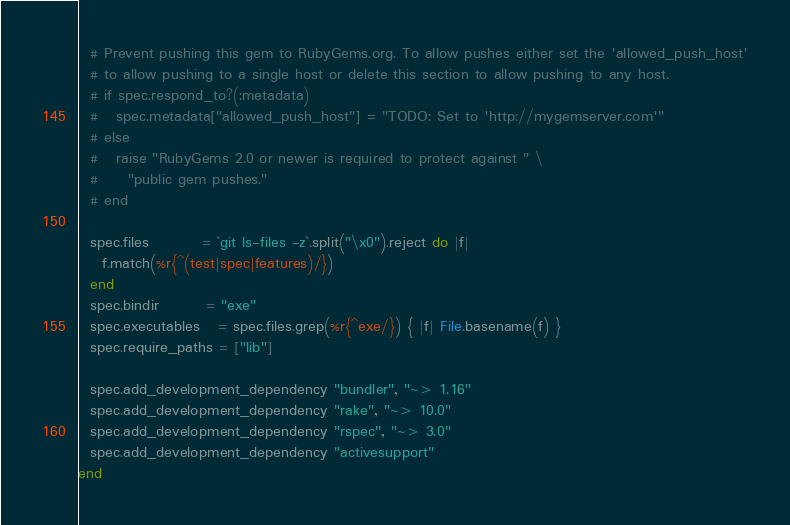<code> <loc_0><loc_0><loc_500><loc_500><_Ruby_>  # Prevent pushing this gem to RubyGems.org. To allow pushes either set the 'allowed_push_host'
  # to allow pushing to a single host or delete this section to allow pushing to any host.
  # if spec.respond_to?(:metadata)
  #   spec.metadata["allowed_push_host"] = "TODO: Set to 'http://mygemserver.com'"
  # else
  #   raise "RubyGems 2.0 or newer is required to protect against " \
  #     "public gem pushes."
  # end

  spec.files         = `git ls-files -z`.split("\x0").reject do |f|
    f.match(%r{^(test|spec|features)/})
  end
  spec.bindir        = "exe"
  spec.executables   = spec.files.grep(%r{^exe/}) { |f| File.basename(f) }
  spec.require_paths = ["lib"]

  spec.add_development_dependency "bundler", "~> 1.16"
  spec.add_development_dependency "rake", "~> 10.0"
  spec.add_development_dependency "rspec", "~> 3.0"
  spec.add_development_dependency "activesupport"
end
</code> 